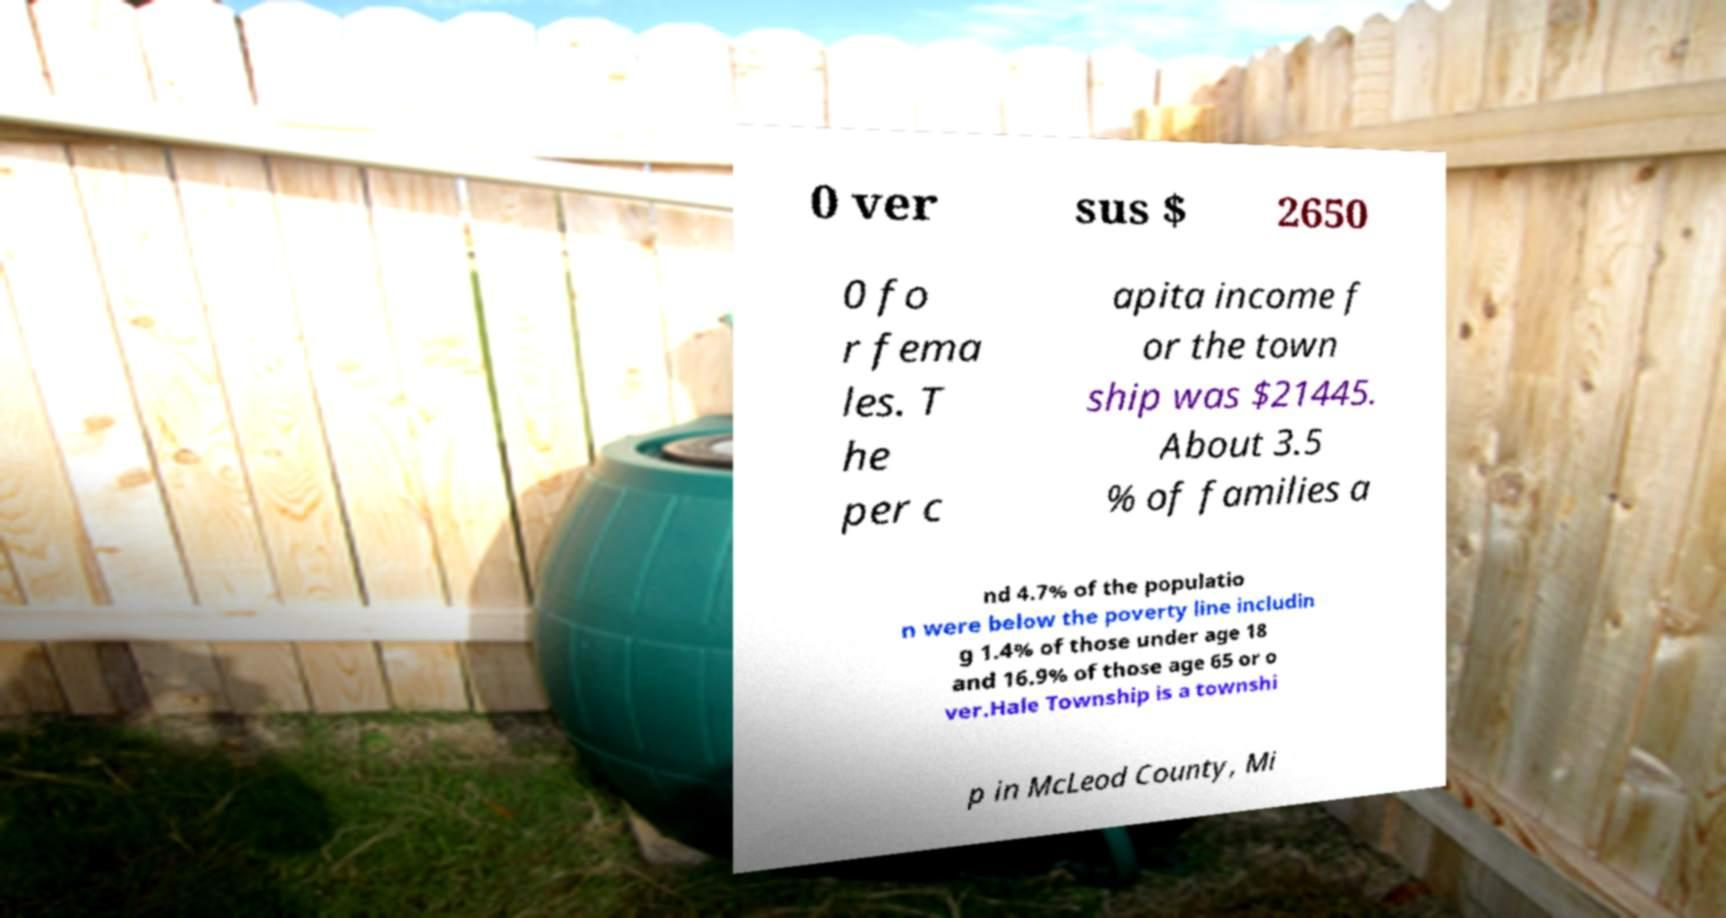For documentation purposes, I need the text within this image transcribed. Could you provide that? 0 ver sus $ 2650 0 fo r fema les. T he per c apita income f or the town ship was $21445. About 3.5 % of families a nd 4.7% of the populatio n were below the poverty line includin g 1.4% of those under age 18 and 16.9% of those age 65 or o ver.Hale Township is a townshi p in McLeod County, Mi 